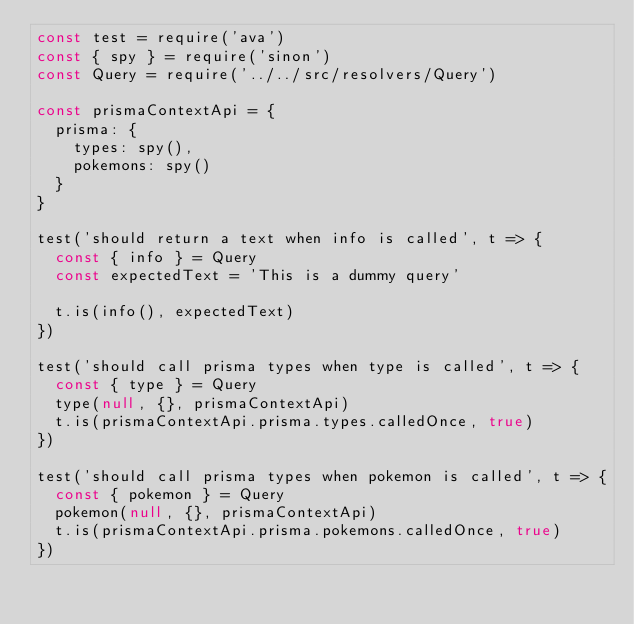Convert code to text. <code><loc_0><loc_0><loc_500><loc_500><_JavaScript_>const test = require('ava')
const { spy } = require('sinon')
const Query = require('../../src/resolvers/Query')

const prismaContextApi = {
  prisma: {
    types: spy(),
    pokemons: spy()
  }
}

test('should return a text when info is called', t => {
  const { info } = Query
  const expectedText = 'This is a dummy query'

  t.is(info(), expectedText)
})

test('should call prisma types when type is called', t => {
  const { type } = Query
  type(null, {}, prismaContextApi)
  t.is(prismaContextApi.prisma.types.calledOnce, true)
})

test('should call prisma types when pokemon is called', t => {
  const { pokemon } = Query
  pokemon(null, {}, prismaContextApi)
  t.is(prismaContextApi.prisma.pokemons.calledOnce, true)
})
</code> 